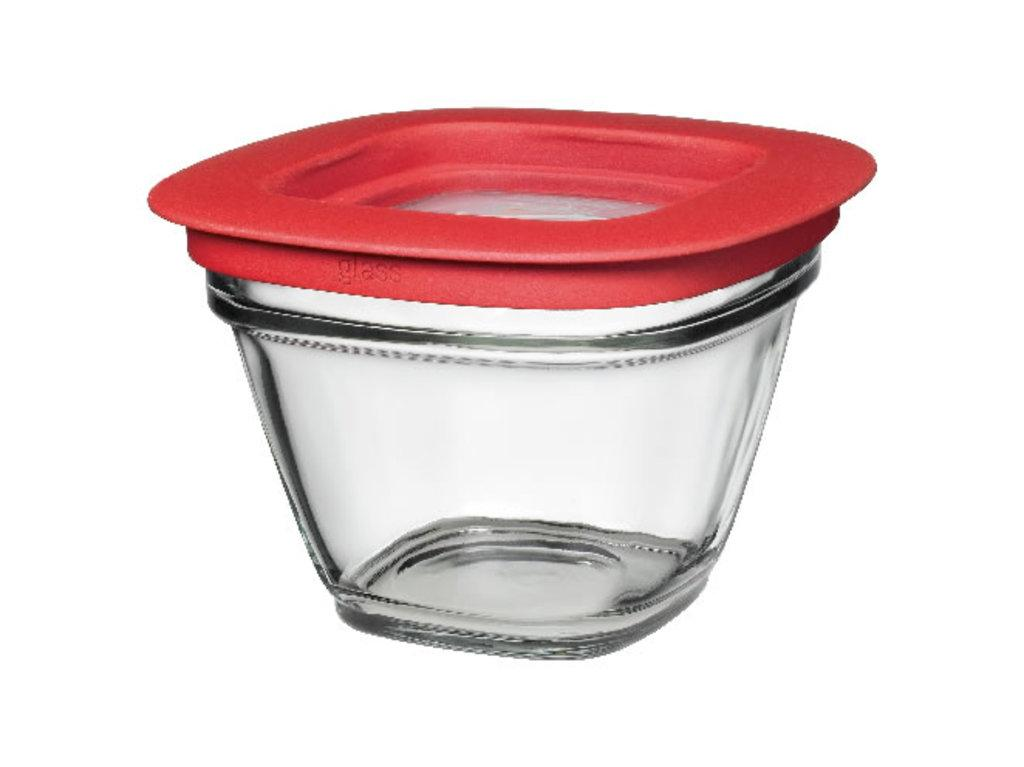What type of container is visible in the image? There is a glass bowl in the image. What color is the lid on the glass bowl? The glass bowl has a red lid. What color is the background of the image? The background of the image is white. What type of tool is being used to cast a spell in the image? There is no tool or spell casting present in the image; it only features a glass bowl with a red lid against a white background. 